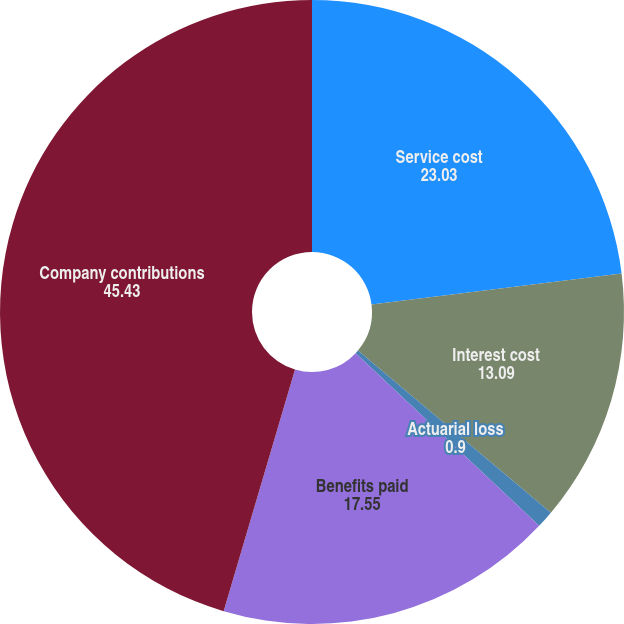<chart> <loc_0><loc_0><loc_500><loc_500><pie_chart><fcel>Service cost<fcel>Interest cost<fcel>Actuarial loss<fcel>Benefits paid<fcel>Company contributions<nl><fcel>23.03%<fcel>13.09%<fcel>0.9%<fcel>17.55%<fcel>45.43%<nl></chart> 